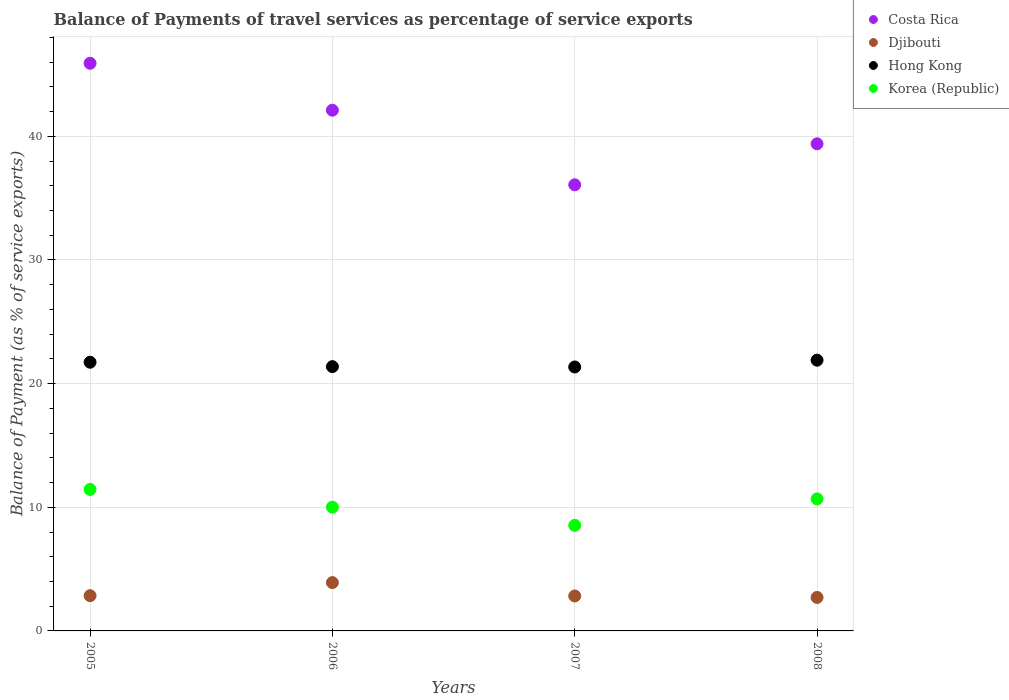How many different coloured dotlines are there?
Give a very brief answer. 4. What is the balance of payments of travel services in Hong Kong in 2008?
Offer a terse response. 21.9. Across all years, what is the maximum balance of payments of travel services in Korea (Republic)?
Your response must be concise. 11.44. Across all years, what is the minimum balance of payments of travel services in Djibouti?
Your answer should be compact. 2.71. In which year was the balance of payments of travel services in Djibouti maximum?
Make the answer very short. 2006. What is the total balance of payments of travel services in Hong Kong in the graph?
Ensure brevity in your answer.  86.35. What is the difference between the balance of payments of travel services in Costa Rica in 2006 and that in 2008?
Make the answer very short. 2.72. What is the difference between the balance of payments of travel services in Djibouti in 2008 and the balance of payments of travel services in Hong Kong in 2007?
Provide a succinct answer. -18.64. What is the average balance of payments of travel services in Costa Rica per year?
Keep it short and to the point. 40.87. In the year 2005, what is the difference between the balance of payments of travel services in Korea (Republic) and balance of payments of travel services in Hong Kong?
Ensure brevity in your answer.  -10.29. In how many years, is the balance of payments of travel services in Djibouti greater than 8 %?
Keep it short and to the point. 0. What is the ratio of the balance of payments of travel services in Hong Kong in 2006 to that in 2007?
Keep it short and to the point. 1. Is the balance of payments of travel services in Djibouti in 2005 less than that in 2007?
Your answer should be very brief. No. What is the difference between the highest and the second highest balance of payments of travel services in Djibouti?
Offer a very short reply. 1.06. What is the difference between the highest and the lowest balance of payments of travel services in Korea (Republic)?
Your response must be concise. 2.91. In how many years, is the balance of payments of travel services in Korea (Republic) greater than the average balance of payments of travel services in Korea (Republic) taken over all years?
Ensure brevity in your answer.  2. Is it the case that in every year, the sum of the balance of payments of travel services in Korea (Republic) and balance of payments of travel services in Hong Kong  is greater than the balance of payments of travel services in Costa Rica?
Give a very brief answer. No. Does the balance of payments of travel services in Djibouti monotonically increase over the years?
Offer a very short reply. No. Is the balance of payments of travel services in Costa Rica strictly greater than the balance of payments of travel services in Korea (Republic) over the years?
Provide a short and direct response. Yes. How many dotlines are there?
Your answer should be very brief. 4. Are the values on the major ticks of Y-axis written in scientific E-notation?
Provide a short and direct response. No. Does the graph contain any zero values?
Ensure brevity in your answer.  No. Does the graph contain grids?
Make the answer very short. Yes. How many legend labels are there?
Offer a terse response. 4. What is the title of the graph?
Make the answer very short. Balance of Payments of travel services as percentage of service exports. Does "Least developed countries" appear as one of the legend labels in the graph?
Provide a short and direct response. No. What is the label or title of the X-axis?
Keep it short and to the point. Years. What is the label or title of the Y-axis?
Your answer should be compact. Balance of Payment (as % of service exports). What is the Balance of Payment (as % of service exports) of Costa Rica in 2005?
Make the answer very short. 45.91. What is the Balance of Payment (as % of service exports) in Djibouti in 2005?
Offer a terse response. 2.85. What is the Balance of Payment (as % of service exports) of Hong Kong in 2005?
Offer a very short reply. 21.73. What is the Balance of Payment (as % of service exports) of Korea (Republic) in 2005?
Offer a terse response. 11.44. What is the Balance of Payment (as % of service exports) of Costa Rica in 2006?
Make the answer very short. 42.11. What is the Balance of Payment (as % of service exports) in Djibouti in 2006?
Your answer should be very brief. 3.91. What is the Balance of Payment (as % of service exports) of Hong Kong in 2006?
Make the answer very short. 21.37. What is the Balance of Payment (as % of service exports) of Korea (Republic) in 2006?
Keep it short and to the point. 10.01. What is the Balance of Payment (as % of service exports) in Costa Rica in 2007?
Your response must be concise. 36.08. What is the Balance of Payment (as % of service exports) in Djibouti in 2007?
Your answer should be very brief. 2.83. What is the Balance of Payment (as % of service exports) in Hong Kong in 2007?
Make the answer very short. 21.34. What is the Balance of Payment (as % of service exports) of Korea (Republic) in 2007?
Provide a short and direct response. 8.54. What is the Balance of Payment (as % of service exports) in Costa Rica in 2008?
Your answer should be compact. 39.39. What is the Balance of Payment (as % of service exports) of Djibouti in 2008?
Offer a terse response. 2.71. What is the Balance of Payment (as % of service exports) in Hong Kong in 2008?
Ensure brevity in your answer.  21.9. What is the Balance of Payment (as % of service exports) of Korea (Republic) in 2008?
Provide a short and direct response. 10.68. Across all years, what is the maximum Balance of Payment (as % of service exports) in Costa Rica?
Offer a very short reply. 45.91. Across all years, what is the maximum Balance of Payment (as % of service exports) of Djibouti?
Provide a short and direct response. 3.91. Across all years, what is the maximum Balance of Payment (as % of service exports) of Hong Kong?
Give a very brief answer. 21.9. Across all years, what is the maximum Balance of Payment (as % of service exports) in Korea (Republic)?
Keep it short and to the point. 11.44. Across all years, what is the minimum Balance of Payment (as % of service exports) in Costa Rica?
Ensure brevity in your answer.  36.08. Across all years, what is the minimum Balance of Payment (as % of service exports) of Djibouti?
Offer a very short reply. 2.71. Across all years, what is the minimum Balance of Payment (as % of service exports) of Hong Kong?
Ensure brevity in your answer.  21.34. Across all years, what is the minimum Balance of Payment (as % of service exports) in Korea (Republic)?
Your answer should be compact. 8.54. What is the total Balance of Payment (as % of service exports) of Costa Rica in the graph?
Your answer should be very brief. 163.49. What is the total Balance of Payment (as % of service exports) of Djibouti in the graph?
Give a very brief answer. 12.29. What is the total Balance of Payment (as % of service exports) in Hong Kong in the graph?
Provide a short and direct response. 86.35. What is the total Balance of Payment (as % of service exports) in Korea (Republic) in the graph?
Make the answer very short. 40.66. What is the difference between the Balance of Payment (as % of service exports) in Costa Rica in 2005 and that in 2006?
Your response must be concise. 3.8. What is the difference between the Balance of Payment (as % of service exports) in Djibouti in 2005 and that in 2006?
Your response must be concise. -1.06. What is the difference between the Balance of Payment (as % of service exports) of Hong Kong in 2005 and that in 2006?
Keep it short and to the point. 0.36. What is the difference between the Balance of Payment (as % of service exports) in Korea (Republic) in 2005 and that in 2006?
Your answer should be very brief. 1.44. What is the difference between the Balance of Payment (as % of service exports) in Costa Rica in 2005 and that in 2007?
Make the answer very short. 9.83. What is the difference between the Balance of Payment (as % of service exports) of Djibouti in 2005 and that in 2007?
Ensure brevity in your answer.  0.02. What is the difference between the Balance of Payment (as % of service exports) of Hong Kong in 2005 and that in 2007?
Ensure brevity in your answer.  0.39. What is the difference between the Balance of Payment (as % of service exports) of Korea (Republic) in 2005 and that in 2007?
Make the answer very short. 2.91. What is the difference between the Balance of Payment (as % of service exports) in Costa Rica in 2005 and that in 2008?
Ensure brevity in your answer.  6.51. What is the difference between the Balance of Payment (as % of service exports) in Djibouti in 2005 and that in 2008?
Give a very brief answer. 0.14. What is the difference between the Balance of Payment (as % of service exports) of Hong Kong in 2005 and that in 2008?
Your answer should be very brief. -0.17. What is the difference between the Balance of Payment (as % of service exports) in Korea (Republic) in 2005 and that in 2008?
Your response must be concise. 0.77. What is the difference between the Balance of Payment (as % of service exports) in Costa Rica in 2006 and that in 2007?
Your response must be concise. 6.03. What is the difference between the Balance of Payment (as % of service exports) of Djibouti in 2006 and that in 2007?
Provide a succinct answer. 1.08. What is the difference between the Balance of Payment (as % of service exports) of Hong Kong in 2006 and that in 2007?
Provide a short and direct response. 0.03. What is the difference between the Balance of Payment (as % of service exports) in Korea (Republic) in 2006 and that in 2007?
Give a very brief answer. 1.47. What is the difference between the Balance of Payment (as % of service exports) in Costa Rica in 2006 and that in 2008?
Your answer should be very brief. 2.72. What is the difference between the Balance of Payment (as % of service exports) of Djibouti in 2006 and that in 2008?
Your answer should be compact. 1.2. What is the difference between the Balance of Payment (as % of service exports) of Hong Kong in 2006 and that in 2008?
Ensure brevity in your answer.  -0.52. What is the difference between the Balance of Payment (as % of service exports) of Korea (Republic) in 2006 and that in 2008?
Give a very brief answer. -0.67. What is the difference between the Balance of Payment (as % of service exports) in Costa Rica in 2007 and that in 2008?
Provide a succinct answer. -3.31. What is the difference between the Balance of Payment (as % of service exports) in Djibouti in 2007 and that in 2008?
Keep it short and to the point. 0.12. What is the difference between the Balance of Payment (as % of service exports) of Hong Kong in 2007 and that in 2008?
Give a very brief answer. -0.55. What is the difference between the Balance of Payment (as % of service exports) of Korea (Republic) in 2007 and that in 2008?
Keep it short and to the point. -2.14. What is the difference between the Balance of Payment (as % of service exports) in Costa Rica in 2005 and the Balance of Payment (as % of service exports) in Djibouti in 2006?
Provide a short and direct response. 42. What is the difference between the Balance of Payment (as % of service exports) of Costa Rica in 2005 and the Balance of Payment (as % of service exports) of Hong Kong in 2006?
Make the answer very short. 24.53. What is the difference between the Balance of Payment (as % of service exports) of Costa Rica in 2005 and the Balance of Payment (as % of service exports) of Korea (Republic) in 2006?
Make the answer very short. 35.9. What is the difference between the Balance of Payment (as % of service exports) of Djibouti in 2005 and the Balance of Payment (as % of service exports) of Hong Kong in 2006?
Provide a succinct answer. -18.52. What is the difference between the Balance of Payment (as % of service exports) of Djibouti in 2005 and the Balance of Payment (as % of service exports) of Korea (Republic) in 2006?
Make the answer very short. -7.16. What is the difference between the Balance of Payment (as % of service exports) of Hong Kong in 2005 and the Balance of Payment (as % of service exports) of Korea (Republic) in 2006?
Your answer should be very brief. 11.72. What is the difference between the Balance of Payment (as % of service exports) of Costa Rica in 2005 and the Balance of Payment (as % of service exports) of Djibouti in 2007?
Provide a succinct answer. 43.08. What is the difference between the Balance of Payment (as % of service exports) of Costa Rica in 2005 and the Balance of Payment (as % of service exports) of Hong Kong in 2007?
Your response must be concise. 24.56. What is the difference between the Balance of Payment (as % of service exports) of Costa Rica in 2005 and the Balance of Payment (as % of service exports) of Korea (Republic) in 2007?
Provide a short and direct response. 37.37. What is the difference between the Balance of Payment (as % of service exports) of Djibouti in 2005 and the Balance of Payment (as % of service exports) of Hong Kong in 2007?
Offer a terse response. -18.49. What is the difference between the Balance of Payment (as % of service exports) in Djibouti in 2005 and the Balance of Payment (as % of service exports) in Korea (Republic) in 2007?
Offer a terse response. -5.69. What is the difference between the Balance of Payment (as % of service exports) of Hong Kong in 2005 and the Balance of Payment (as % of service exports) of Korea (Republic) in 2007?
Keep it short and to the point. 13.19. What is the difference between the Balance of Payment (as % of service exports) of Costa Rica in 2005 and the Balance of Payment (as % of service exports) of Djibouti in 2008?
Your answer should be very brief. 43.2. What is the difference between the Balance of Payment (as % of service exports) in Costa Rica in 2005 and the Balance of Payment (as % of service exports) in Hong Kong in 2008?
Give a very brief answer. 24.01. What is the difference between the Balance of Payment (as % of service exports) in Costa Rica in 2005 and the Balance of Payment (as % of service exports) in Korea (Republic) in 2008?
Your response must be concise. 35.23. What is the difference between the Balance of Payment (as % of service exports) of Djibouti in 2005 and the Balance of Payment (as % of service exports) of Hong Kong in 2008?
Provide a succinct answer. -19.05. What is the difference between the Balance of Payment (as % of service exports) of Djibouti in 2005 and the Balance of Payment (as % of service exports) of Korea (Republic) in 2008?
Offer a very short reply. -7.83. What is the difference between the Balance of Payment (as % of service exports) in Hong Kong in 2005 and the Balance of Payment (as % of service exports) in Korea (Republic) in 2008?
Offer a terse response. 11.05. What is the difference between the Balance of Payment (as % of service exports) in Costa Rica in 2006 and the Balance of Payment (as % of service exports) in Djibouti in 2007?
Your response must be concise. 39.28. What is the difference between the Balance of Payment (as % of service exports) of Costa Rica in 2006 and the Balance of Payment (as % of service exports) of Hong Kong in 2007?
Your answer should be very brief. 20.77. What is the difference between the Balance of Payment (as % of service exports) in Costa Rica in 2006 and the Balance of Payment (as % of service exports) in Korea (Republic) in 2007?
Offer a very short reply. 33.57. What is the difference between the Balance of Payment (as % of service exports) in Djibouti in 2006 and the Balance of Payment (as % of service exports) in Hong Kong in 2007?
Provide a succinct answer. -17.44. What is the difference between the Balance of Payment (as % of service exports) of Djibouti in 2006 and the Balance of Payment (as % of service exports) of Korea (Republic) in 2007?
Your answer should be very brief. -4.63. What is the difference between the Balance of Payment (as % of service exports) in Hong Kong in 2006 and the Balance of Payment (as % of service exports) in Korea (Republic) in 2007?
Your response must be concise. 12.84. What is the difference between the Balance of Payment (as % of service exports) of Costa Rica in 2006 and the Balance of Payment (as % of service exports) of Djibouti in 2008?
Provide a succinct answer. 39.4. What is the difference between the Balance of Payment (as % of service exports) of Costa Rica in 2006 and the Balance of Payment (as % of service exports) of Hong Kong in 2008?
Keep it short and to the point. 20.21. What is the difference between the Balance of Payment (as % of service exports) of Costa Rica in 2006 and the Balance of Payment (as % of service exports) of Korea (Republic) in 2008?
Ensure brevity in your answer.  31.44. What is the difference between the Balance of Payment (as % of service exports) in Djibouti in 2006 and the Balance of Payment (as % of service exports) in Hong Kong in 2008?
Provide a succinct answer. -17.99. What is the difference between the Balance of Payment (as % of service exports) in Djibouti in 2006 and the Balance of Payment (as % of service exports) in Korea (Republic) in 2008?
Give a very brief answer. -6.77. What is the difference between the Balance of Payment (as % of service exports) of Hong Kong in 2006 and the Balance of Payment (as % of service exports) of Korea (Republic) in 2008?
Provide a short and direct response. 10.7. What is the difference between the Balance of Payment (as % of service exports) of Costa Rica in 2007 and the Balance of Payment (as % of service exports) of Djibouti in 2008?
Your answer should be very brief. 33.37. What is the difference between the Balance of Payment (as % of service exports) of Costa Rica in 2007 and the Balance of Payment (as % of service exports) of Hong Kong in 2008?
Your answer should be compact. 14.18. What is the difference between the Balance of Payment (as % of service exports) in Costa Rica in 2007 and the Balance of Payment (as % of service exports) in Korea (Republic) in 2008?
Keep it short and to the point. 25.4. What is the difference between the Balance of Payment (as % of service exports) in Djibouti in 2007 and the Balance of Payment (as % of service exports) in Hong Kong in 2008?
Your answer should be compact. -19.07. What is the difference between the Balance of Payment (as % of service exports) in Djibouti in 2007 and the Balance of Payment (as % of service exports) in Korea (Republic) in 2008?
Your answer should be compact. -7.85. What is the difference between the Balance of Payment (as % of service exports) in Hong Kong in 2007 and the Balance of Payment (as % of service exports) in Korea (Republic) in 2008?
Your answer should be very brief. 10.67. What is the average Balance of Payment (as % of service exports) in Costa Rica per year?
Provide a succinct answer. 40.87. What is the average Balance of Payment (as % of service exports) of Djibouti per year?
Provide a succinct answer. 3.07. What is the average Balance of Payment (as % of service exports) of Hong Kong per year?
Give a very brief answer. 21.59. What is the average Balance of Payment (as % of service exports) in Korea (Republic) per year?
Give a very brief answer. 10.17. In the year 2005, what is the difference between the Balance of Payment (as % of service exports) of Costa Rica and Balance of Payment (as % of service exports) of Djibouti?
Your answer should be very brief. 43.06. In the year 2005, what is the difference between the Balance of Payment (as % of service exports) of Costa Rica and Balance of Payment (as % of service exports) of Hong Kong?
Ensure brevity in your answer.  24.18. In the year 2005, what is the difference between the Balance of Payment (as % of service exports) in Costa Rica and Balance of Payment (as % of service exports) in Korea (Republic)?
Provide a short and direct response. 34.46. In the year 2005, what is the difference between the Balance of Payment (as % of service exports) in Djibouti and Balance of Payment (as % of service exports) in Hong Kong?
Your answer should be compact. -18.88. In the year 2005, what is the difference between the Balance of Payment (as % of service exports) of Djibouti and Balance of Payment (as % of service exports) of Korea (Republic)?
Your answer should be very brief. -8.59. In the year 2005, what is the difference between the Balance of Payment (as % of service exports) in Hong Kong and Balance of Payment (as % of service exports) in Korea (Republic)?
Make the answer very short. 10.29. In the year 2006, what is the difference between the Balance of Payment (as % of service exports) of Costa Rica and Balance of Payment (as % of service exports) of Djibouti?
Ensure brevity in your answer.  38.2. In the year 2006, what is the difference between the Balance of Payment (as % of service exports) of Costa Rica and Balance of Payment (as % of service exports) of Hong Kong?
Give a very brief answer. 20.74. In the year 2006, what is the difference between the Balance of Payment (as % of service exports) of Costa Rica and Balance of Payment (as % of service exports) of Korea (Republic)?
Keep it short and to the point. 32.1. In the year 2006, what is the difference between the Balance of Payment (as % of service exports) of Djibouti and Balance of Payment (as % of service exports) of Hong Kong?
Offer a terse response. -17.47. In the year 2006, what is the difference between the Balance of Payment (as % of service exports) of Djibouti and Balance of Payment (as % of service exports) of Korea (Republic)?
Offer a terse response. -6.1. In the year 2006, what is the difference between the Balance of Payment (as % of service exports) in Hong Kong and Balance of Payment (as % of service exports) in Korea (Republic)?
Keep it short and to the point. 11.37. In the year 2007, what is the difference between the Balance of Payment (as % of service exports) in Costa Rica and Balance of Payment (as % of service exports) in Djibouti?
Give a very brief answer. 33.25. In the year 2007, what is the difference between the Balance of Payment (as % of service exports) in Costa Rica and Balance of Payment (as % of service exports) in Hong Kong?
Give a very brief answer. 14.74. In the year 2007, what is the difference between the Balance of Payment (as % of service exports) in Costa Rica and Balance of Payment (as % of service exports) in Korea (Republic)?
Offer a terse response. 27.54. In the year 2007, what is the difference between the Balance of Payment (as % of service exports) of Djibouti and Balance of Payment (as % of service exports) of Hong Kong?
Your answer should be very brief. -18.52. In the year 2007, what is the difference between the Balance of Payment (as % of service exports) in Djibouti and Balance of Payment (as % of service exports) in Korea (Republic)?
Provide a succinct answer. -5.71. In the year 2007, what is the difference between the Balance of Payment (as % of service exports) of Hong Kong and Balance of Payment (as % of service exports) of Korea (Republic)?
Offer a very short reply. 12.81. In the year 2008, what is the difference between the Balance of Payment (as % of service exports) of Costa Rica and Balance of Payment (as % of service exports) of Djibouti?
Your answer should be compact. 36.69. In the year 2008, what is the difference between the Balance of Payment (as % of service exports) in Costa Rica and Balance of Payment (as % of service exports) in Hong Kong?
Give a very brief answer. 17.5. In the year 2008, what is the difference between the Balance of Payment (as % of service exports) of Costa Rica and Balance of Payment (as % of service exports) of Korea (Republic)?
Offer a very short reply. 28.72. In the year 2008, what is the difference between the Balance of Payment (as % of service exports) of Djibouti and Balance of Payment (as % of service exports) of Hong Kong?
Your response must be concise. -19.19. In the year 2008, what is the difference between the Balance of Payment (as % of service exports) in Djibouti and Balance of Payment (as % of service exports) in Korea (Republic)?
Offer a very short reply. -7.97. In the year 2008, what is the difference between the Balance of Payment (as % of service exports) of Hong Kong and Balance of Payment (as % of service exports) of Korea (Republic)?
Provide a succinct answer. 11.22. What is the ratio of the Balance of Payment (as % of service exports) in Costa Rica in 2005 to that in 2006?
Offer a terse response. 1.09. What is the ratio of the Balance of Payment (as % of service exports) of Djibouti in 2005 to that in 2006?
Provide a short and direct response. 0.73. What is the ratio of the Balance of Payment (as % of service exports) in Hong Kong in 2005 to that in 2006?
Your answer should be compact. 1.02. What is the ratio of the Balance of Payment (as % of service exports) of Korea (Republic) in 2005 to that in 2006?
Provide a short and direct response. 1.14. What is the ratio of the Balance of Payment (as % of service exports) in Costa Rica in 2005 to that in 2007?
Offer a terse response. 1.27. What is the ratio of the Balance of Payment (as % of service exports) in Djibouti in 2005 to that in 2007?
Provide a short and direct response. 1.01. What is the ratio of the Balance of Payment (as % of service exports) of Korea (Republic) in 2005 to that in 2007?
Provide a succinct answer. 1.34. What is the ratio of the Balance of Payment (as % of service exports) of Costa Rica in 2005 to that in 2008?
Keep it short and to the point. 1.17. What is the ratio of the Balance of Payment (as % of service exports) in Djibouti in 2005 to that in 2008?
Give a very brief answer. 1.05. What is the ratio of the Balance of Payment (as % of service exports) in Hong Kong in 2005 to that in 2008?
Your answer should be compact. 0.99. What is the ratio of the Balance of Payment (as % of service exports) in Korea (Republic) in 2005 to that in 2008?
Your response must be concise. 1.07. What is the ratio of the Balance of Payment (as % of service exports) in Costa Rica in 2006 to that in 2007?
Provide a short and direct response. 1.17. What is the ratio of the Balance of Payment (as % of service exports) in Djibouti in 2006 to that in 2007?
Make the answer very short. 1.38. What is the ratio of the Balance of Payment (as % of service exports) of Hong Kong in 2006 to that in 2007?
Provide a succinct answer. 1. What is the ratio of the Balance of Payment (as % of service exports) of Korea (Republic) in 2006 to that in 2007?
Ensure brevity in your answer.  1.17. What is the ratio of the Balance of Payment (as % of service exports) of Costa Rica in 2006 to that in 2008?
Your answer should be compact. 1.07. What is the ratio of the Balance of Payment (as % of service exports) in Djibouti in 2006 to that in 2008?
Your answer should be very brief. 1.44. What is the ratio of the Balance of Payment (as % of service exports) of Hong Kong in 2006 to that in 2008?
Make the answer very short. 0.98. What is the ratio of the Balance of Payment (as % of service exports) in Korea (Republic) in 2006 to that in 2008?
Offer a terse response. 0.94. What is the ratio of the Balance of Payment (as % of service exports) in Costa Rica in 2007 to that in 2008?
Ensure brevity in your answer.  0.92. What is the ratio of the Balance of Payment (as % of service exports) of Djibouti in 2007 to that in 2008?
Provide a short and direct response. 1.04. What is the ratio of the Balance of Payment (as % of service exports) of Hong Kong in 2007 to that in 2008?
Give a very brief answer. 0.97. What is the ratio of the Balance of Payment (as % of service exports) in Korea (Republic) in 2007 to that in 2008?
Keep it short and to the point. 0.8. What is the difference between the highest and the second highest Balance of Payment (as % of service exports) of Costa Rica?
Your response must be concise. 3.8. What is the difference between the highest and the second highest Balance of Payment (as % of service exports) of Djibouti?
Provide a succinct answer. 1.06. What is the difference between the highest and the second highest Balance of Payment (as % of service exports) of Hong Kong?
Ensure brevity in your answer.  0.17. What is the difference between the highest and the second highest Balance of Payment (as % of service exports) of Korea (Republic)?
Give a very brief answer. 0.77. What is the difference between the highest and the lowest Balance of Payment (as % of service exports) in Costa Rica?
Provide a succinct answer. 9.83. What is the difference between the highest and the lowest Balance of Payment (as % of service exports) in Djibouti?
Keep it short and to the point. 1.2. What is the difference between the highest and the lowest Balance of Payment (as % of service exports) in Hong Kong?
Make the answer very short. 0.55. What is the difference between the highest and the lowest Balance of Payment (as % of service exports) in Korea (Republic)?
Your answer should be very brief. 2.91. 